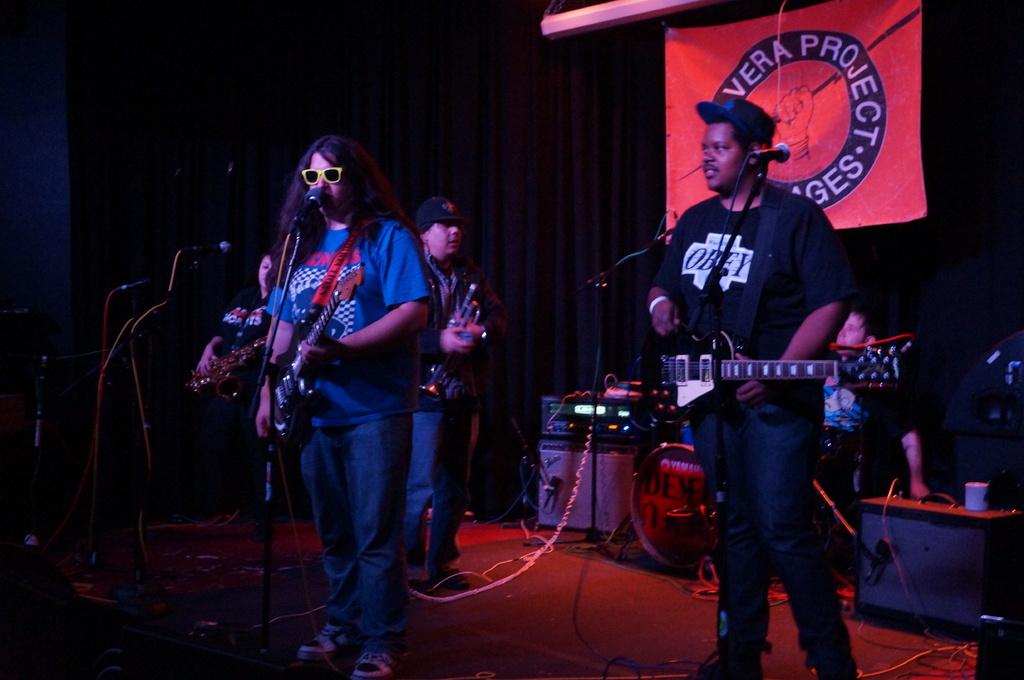What is happening in the image involving a group of people? There is a group of people in the image, and they are on a stage. What are the people on the stage doing? The people are playing guitar and singing on a microphone. What type of polish is being applied to the guitar in the image? There is no indication in the image that any polish is being applied to the guitar. 